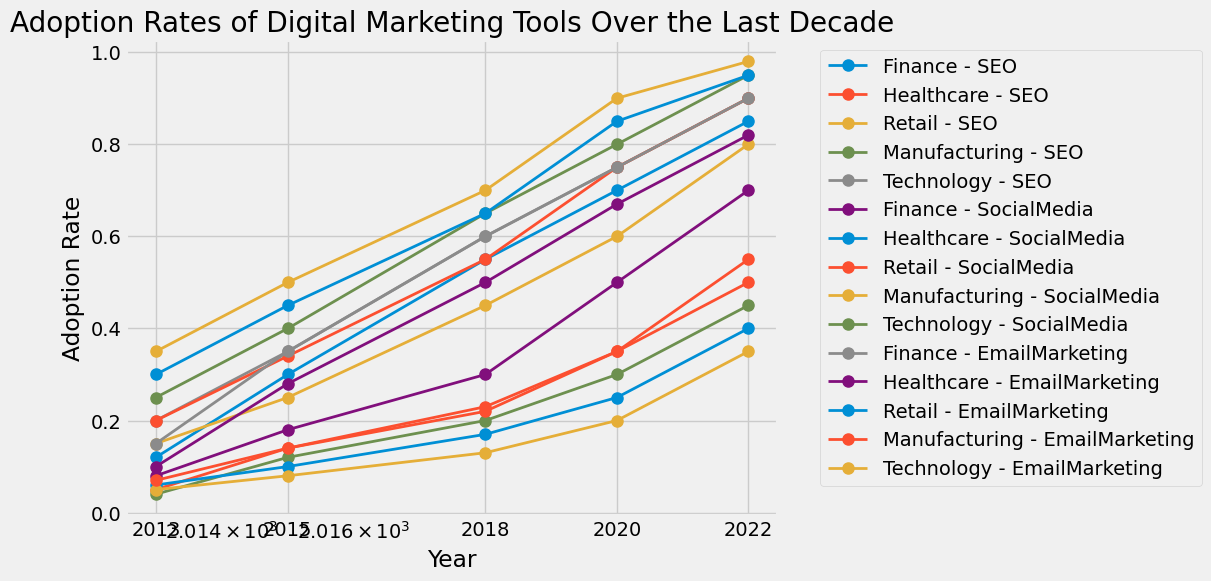What is the overall trend of SEO adoption in the Technology industry over the years? By observing the Technology - SEO line, we see a consistent increase in the adoption rate from 0.20 in 2013 to 0.90 in 2022.
Answer: Increasing How does the adoption rate of SocialMedia in Healthcare compare to Retail in 2022? By locating the corresponding lines, SocialMedia adoption in Healthcare is at 0.40, while in Retail it is at 0.90.
Answer: Retail has a higher adoption rate What was the adoption rate of EmailMarketing in Finance in 2015 compared to 2018? The plot shows that the Finance - EmailMarketing adoption rate was 0.35 in 2015 and 0.60 in 2018, indicating an increase.
Answer: Higher in 2018 Which industry had the highest adoption rate of SEO in 2020? By identifying the point in 2020 for each industry-SEO line, Technology shows the highest adoption rate at 0.75.
Answer: Technology What is the total increase in the adoption rate of SocialMedia in the Manufacturing sector from 2013 to 2022? The adoption rate in Manufacturing for SocialMedia was 0.05 in 2013 and 0.35 in 2022. The increase is 0.35 - 0.05 = 0.30.
Answer: 0.30 How does the adoption rate of EmailMarketing in Healthcare in 2022 compare to its adoption rate in Retail in 2018? The Healthcare - EmailMarketing adoption rate in 2022 is 0.70, while the Retail - EmailMarketing adoption rate in 2018 is 0.65.
Answer: Higher in Healthcare in 2022 Among SEO, SocialMedia, and EmailMarketing, which tool had the most significant increase in adoption rate in the Finance industry from 2013 to 2022? For Finance: SEO increased from 0.12 to 0.85 (+0.73); SocialMedia from 0.10 to 0.82 (+0.72); EmailMarketing from 0.15 to 0.90 (+0.75). EmailMarketing had the most significant increase.
Answer: EmailMarketing What can be observed about the adoption rate of SEO in the Manufacturing industry from 2015 to 2020? The adoption rate for Manufacturing - SEO increased from 0.12 in 2015 to 0.30 in 2020.
Answer: It increased Which tool shows the smallest adoption rate increase in the Technology industry from 2013 to 2022? Comparing the increases in Technology: SEO from 0.20 to 0.90 (+0.70); SocialMedia from 0.25 to 0.95 (+0.70); EmailMarketing from 0.35 to 0.98 (+0.63). EmailMarketing shows the smallest increase.
Answer: EmailMarketing 